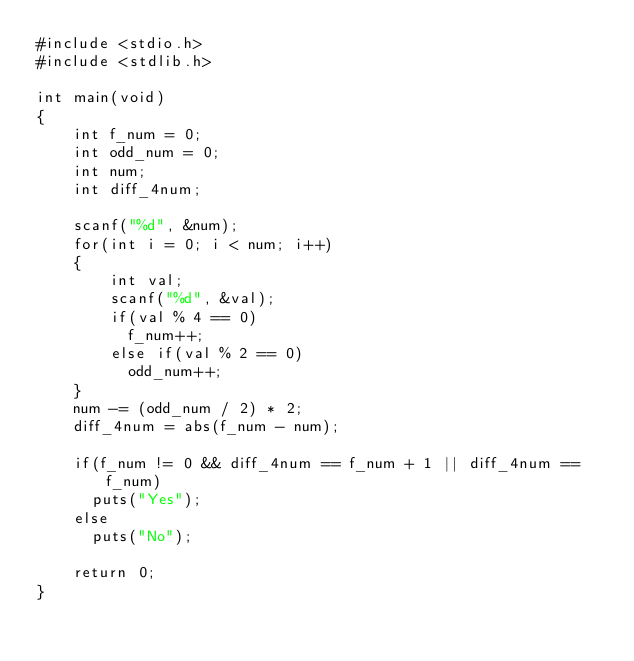<code> <loc_0><loc_0><loc_500><loc_500><_C_>#include <stdio.h>
#include <stdlib.h>

int main(void)
{
	int f_num = 0;
    int odd_num = 0;
    int num;
    int diff_4num;
  
    scanf("%d", &num);
	for(int i = 0; i < num; i++)
	{
        int val;
        scanf("%d", &val);
        if(val % 4 == 0)
          f_num++;
        else if(val % 2 == 0)
          odd_num++;
	}
    num -= (odd_num / 2) * 2;
    diff_4num = abs(f_num - num);
  
    if(f_num != 0 && diff_4num == f_num + 1 || diff_4num == f_num)
      puts("Yes");
    else 
      puts("No");
  
    return 0;
}
</code> 